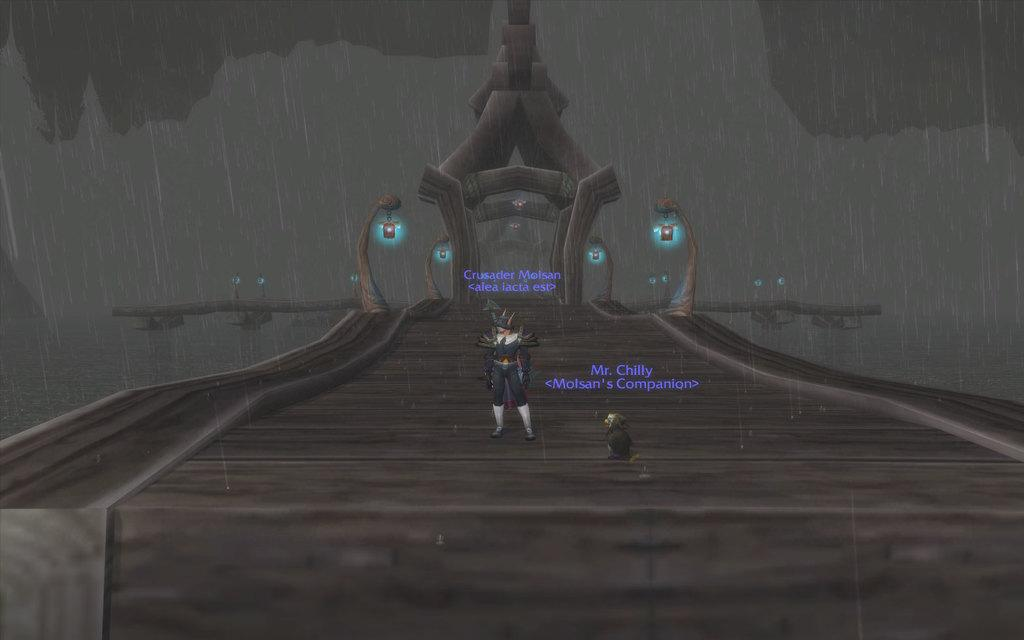What type of image is being described? The image is graphical in nature. What objects can be seen in the image? There are poles and lights in the image. Is there any text present in the image? Yes, there is text in the image. Are there any people in the image? Yes, two persons are standing in the image. What type of ship can be seen sailing in the image? There is no ship present in the image; it is a graphical image with poles, lights, text, and two persons standing. Can you describe the spark emitted by the lights in the image? There is no mention of a spark in the image; the lights are simply present in the graphical representation. 